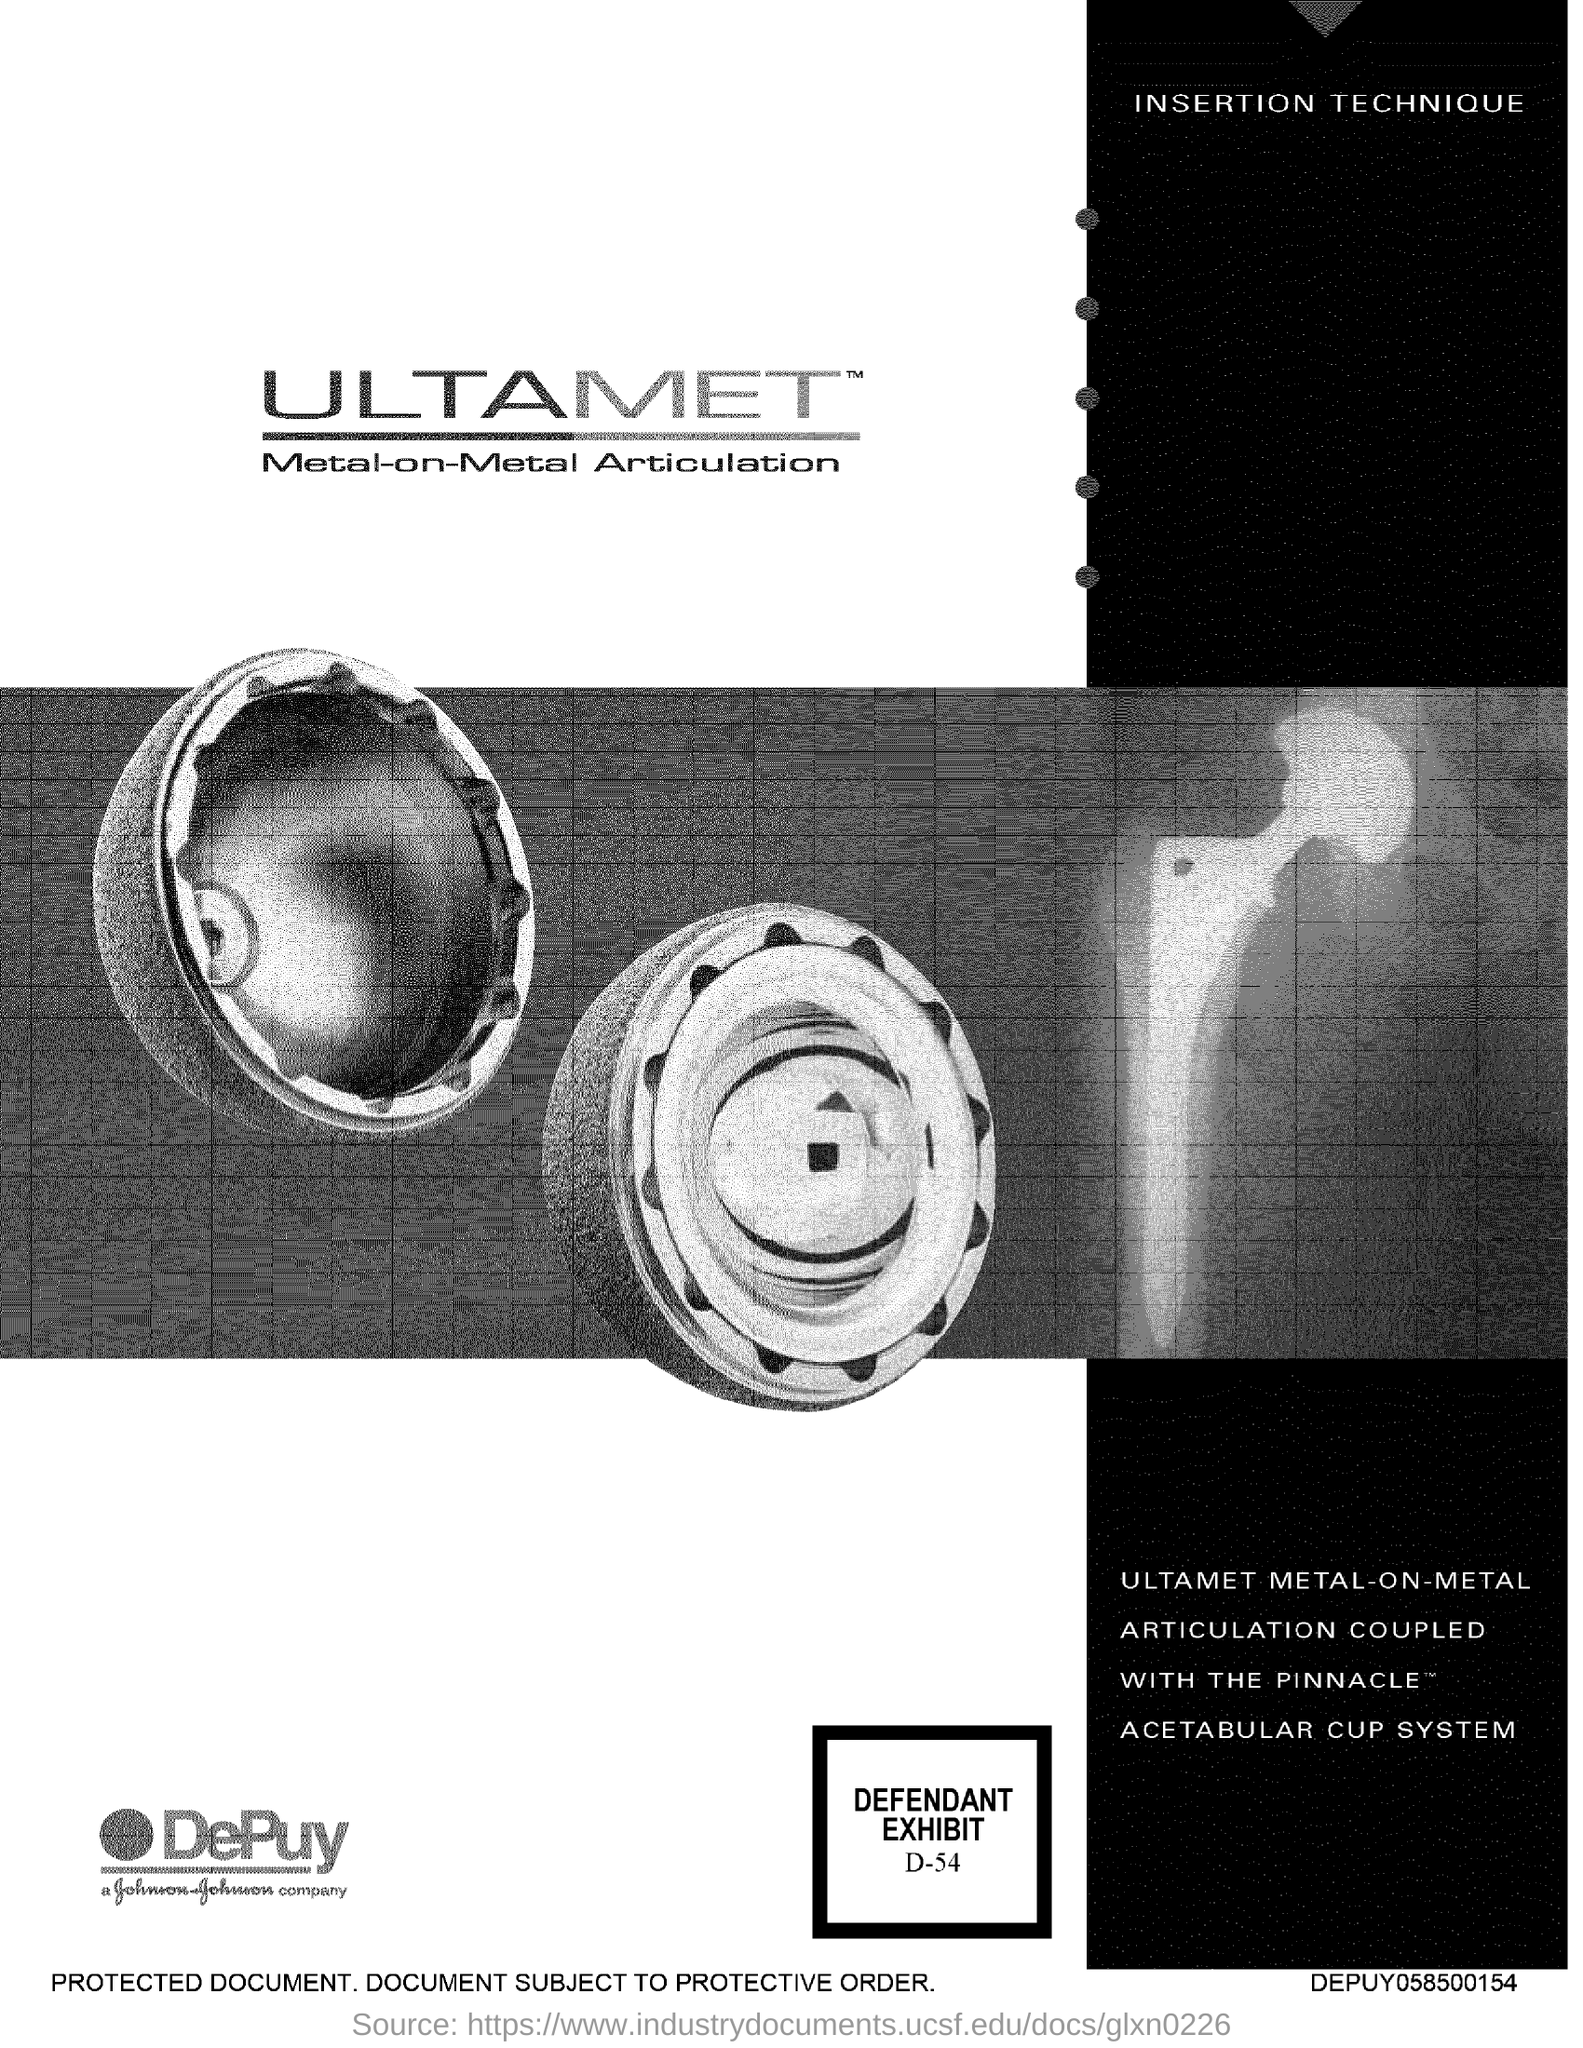Give some essential details in this illustration. The defendant's exhibit number is D-54," stated the prosecutor. 